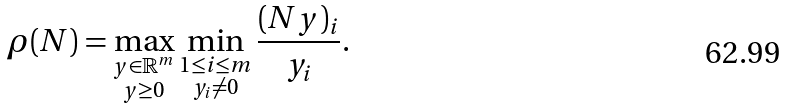<formula> <loc_0><loc_0><loc_500><loc_500>\rho ( N ) = \max _ { \substack { y \in \mathbb { R } ^ { m } \\ y \geq 0 } } \min _ { \substack { 1 \leq i \leq m \\ y _ { i } \neq 0 } } \frac { ( N y ) _ { i } } { y _ { i } } .</formula> 